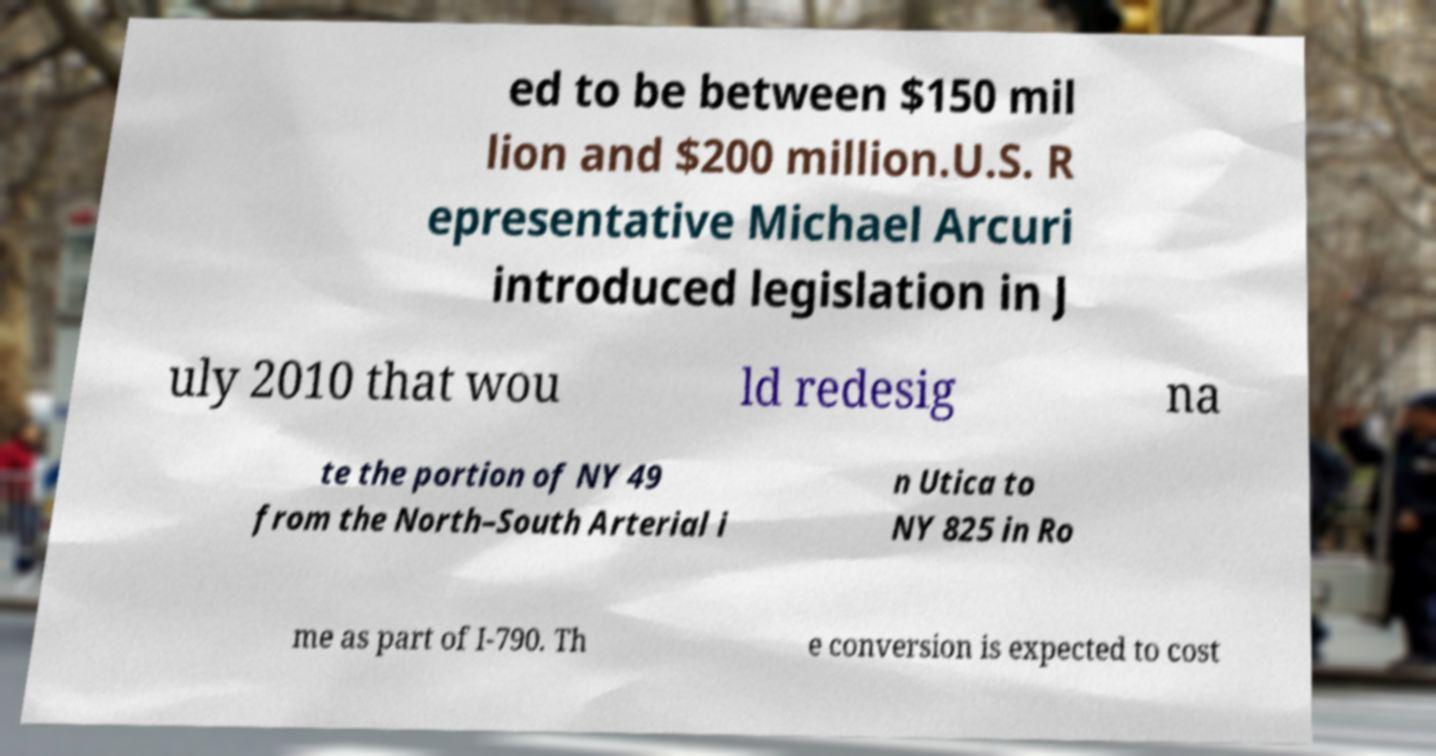Please read and relay the text visible in this image. What does it say? ed to be between $150 mil lion and $200 million.U.S. R epresentative Michael Arcuri introduced legislation in J uly 2010 that wou ld redesig na te the portion of NY 49 from the North–South Arterial i n Utica to NY 825 in Ro me as part of I-790. Th e conversion is expected to cost 